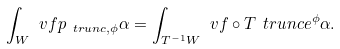<formula> <loc_0><loc_0><loc_500><loc_500>\int _ { W } \ v f \L p _ { \ t r u n c , \phi } \alpha = \int _ { T ^ { - 1 } W } \ v f \circ T \ t r u n c e ^ { \phi } \alpha .</formula> 